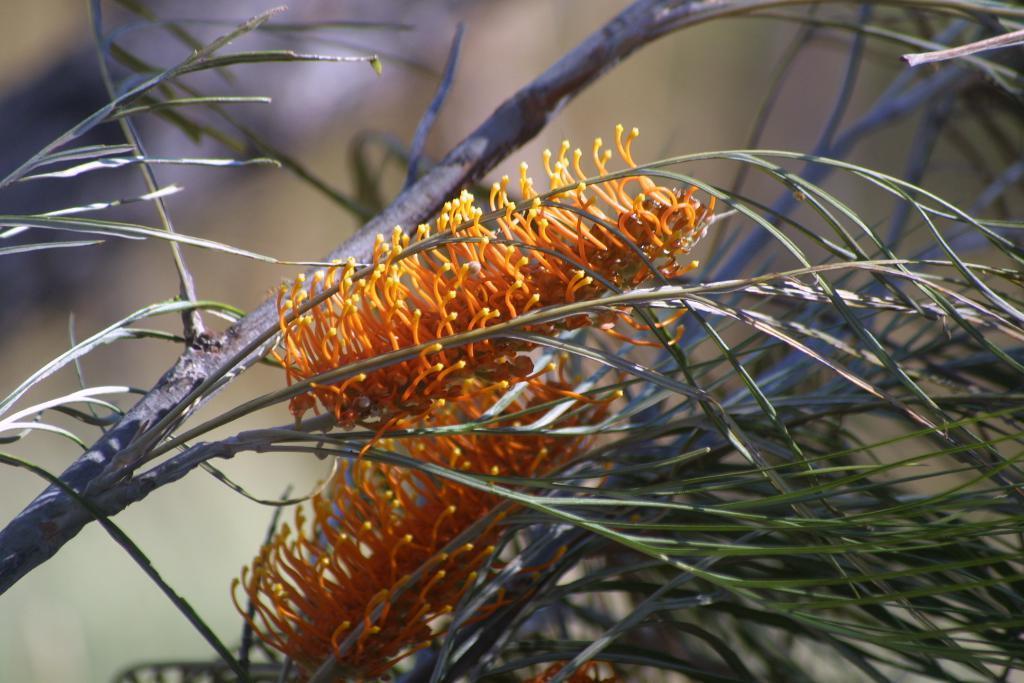Describe this image in one or two sentences. This picture is clicked outside. In the foreground we can see the green leaves and some objects which seems to be the flowers and we can see some objects. In the background we can see some other objects. The background of the image is blurry. 